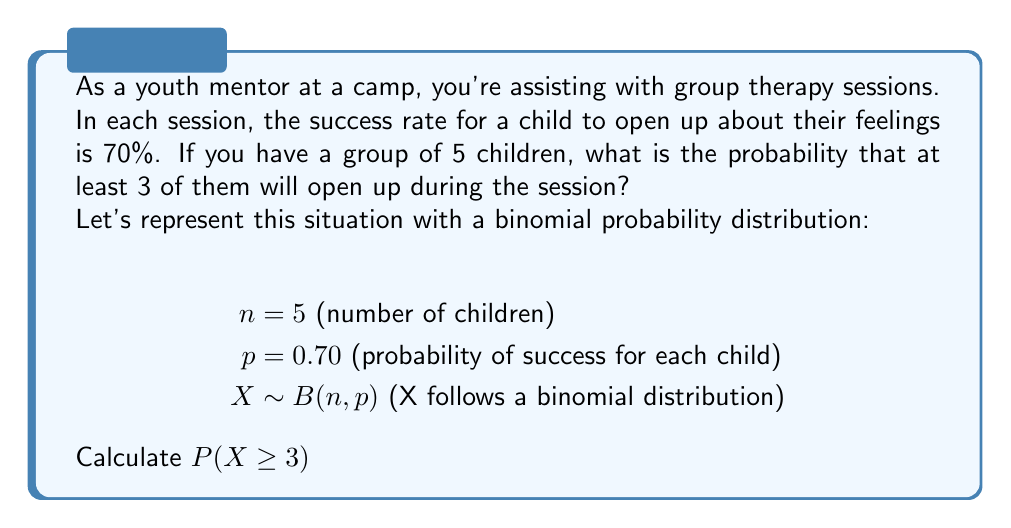What is the answer to this math problem? To solve this problem, we'll use the binomial probability distribution formula and the complement rule:

1) First, let's recall the binomial probability formula:
   $P(X = k) = \binom{n}{k} p^k (1-p)^{n-k}$

2) We need to find $P(X \geq 3)$, which is equivalent to:
   $P(X = 3) + P(X = 4) + P(X = 5)$

3) However, it's often easier to calculate the complement:
   $P(X \geq 3) = 1 - P(X < 3) = 1 - [P(X = 0) + P(X = 1) + P(X = 2)]$

4) Let's calculate each probability:

   $P(X = 0) = \binom{5}{0} (0.7)^0 (0.3)^5 = 1 \cdot 1 \cdot 0.00243 = 0.00243$

   $P(X = 1) = \binom{5}{1} (0.7)^1 (0.3)^4 = 5 \cdot 0.7 \cdot 0.0081 = 0.02835$

   $P(X = 2) = \binom{5}{2} (0.7)^2 (0.3)^3 = 10 \cdot 0.49 \cdot 0.027 = 0.13230$

5) Now, we can sum these probabilities:
   $P(X < 3) = 0.00243 + 0.02835 + 0.13230 = 0.16308$

6) Finally, we can calculate the probability we're looking for:
   $P(X \geq 3) = 1 - P(X < 3) = 1 - 0.16308 = 0.83692$
Answer: 0.83692 